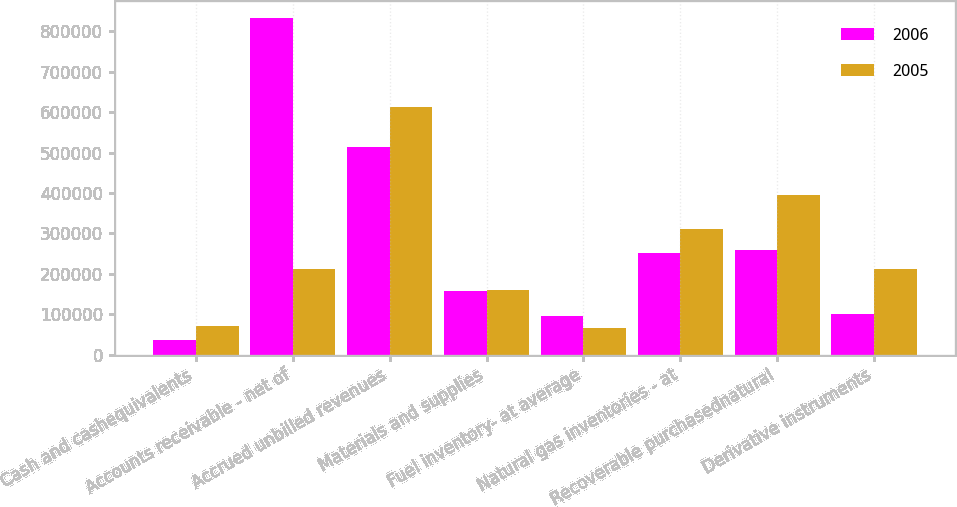<chart> <loc_0><loc_0><loc_500><loc_500><stacked_bar_chart><ecel><fcel>Cash and cashequivalents<fcel>Accounts receivable - net of<fcel>Accrued unbilled revenues<fcel>Materials and supplies<fcel>Fuel inventory- at average<fcel>Natural gas inventories - at<fcel>Recoverable purchasednatural<fcel>Derivative instruments<nl><fcel>2006<fcel>37458<fcel>833293<fcel>514300<fcel>158721<fcel>95651<fcel>251818<fcel>258600<fcel>101562<nl><fcel>2005<fcel>72196<fcel>213138<fcel>614016<fcel>159560<fcel>64987<fcel>310610<fcel>395070<fcel>213138<nl></chart> 